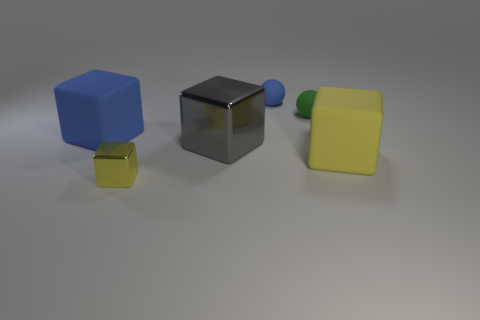Subtract all large blue matte cubes. How many cubes are left? 3 Add 2 small green matte balls. How many objects exist? 8 Subtract all green spheres. How many spheres are left? 1 Subtract all blocks. How many objects are left? 2 Subtract 1 balls. How many balls are left? 1 Subtract all yellow spheres. How many yellow blocks are left? 2 Subtract 2 yellow cubes. How many objects are left? 4 Subtract all yellow cubes. Subtract all cyan cylinders. How many cubes are left? 2 Subtract all green matte objects. Subtract all big metal objects. How many objects are left? 4 Add 6 matte things. How many matte things are left? 10 